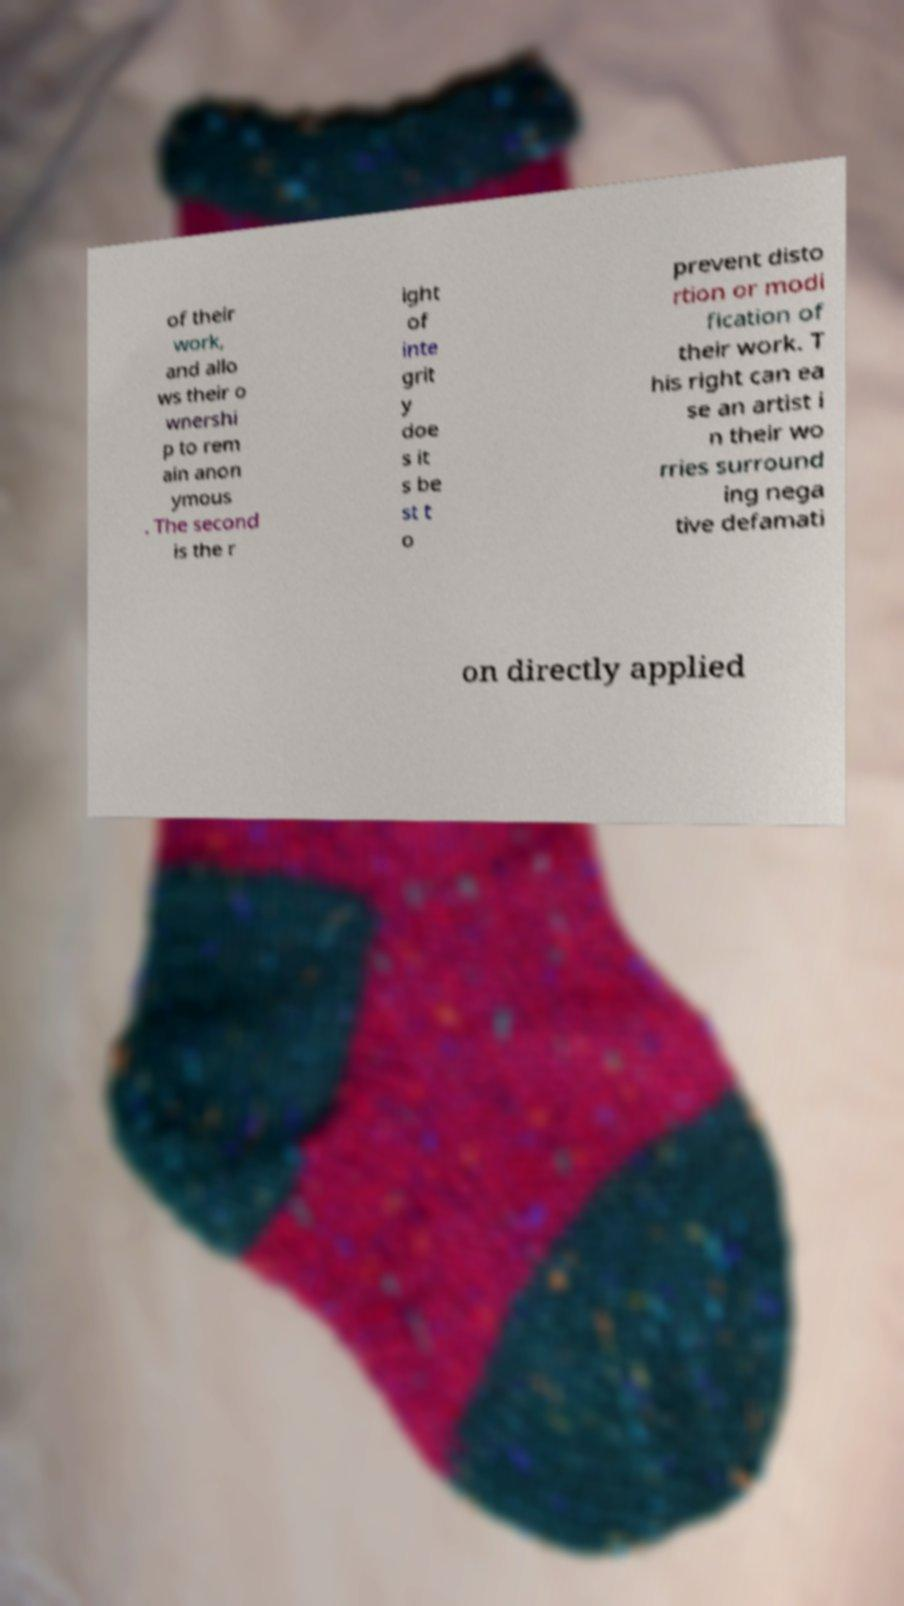Please read and relay the text visible in this image. What does it say? of their work, and allo ws their o wnershi p to rem ain anon ymous . The second is the r ight of inte grit y doe s it s be st t o prevent disto rtion or modi fication of their work. T his right can ea se an artist i n their wo rries surround ing nega tive defamati on directly applied 